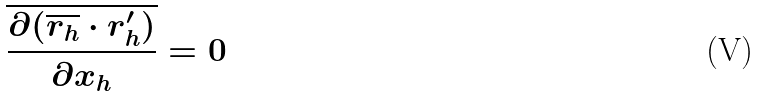<formula> <loc_0><loc_0><loc_500><loc_500>\overline { \frac { \partial ( \overline { r _ { h } } \cdot r _ { h } ^ { \prime } ) } { \partial x _ { h } } } = 0</formula> 